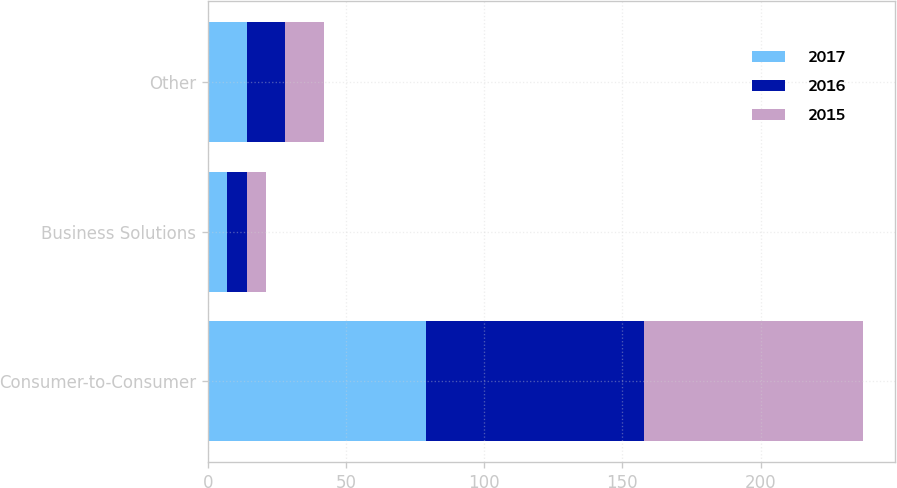<chart> <loc_0><loc_0><loc_500><loc_500><stacked_bar_chart><ecel><fcel>Consumer-to-Consumer<fcel>Business Solutions<fcel>Other<nl><fcel>2017<fcel>79<fcel>7<fcel>14<nl><fcel>2016<fcel>79<fcel>7<fcel>14<nl><fcel>2015<fcel>79<fcel>7<fcel>14<nl></chart> 